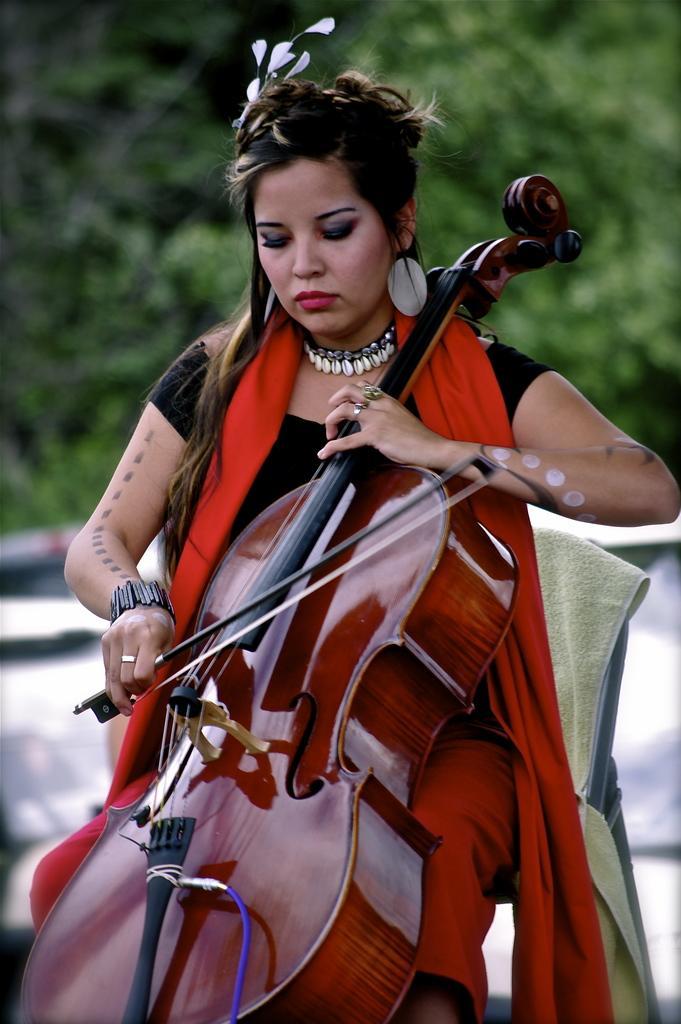In one or two sentences, can you explain what this image depicts? This image is clicked outside. There is a woman sitting in a chair and playing violin. She is wearing black and red dress. In the background, there are trees. 